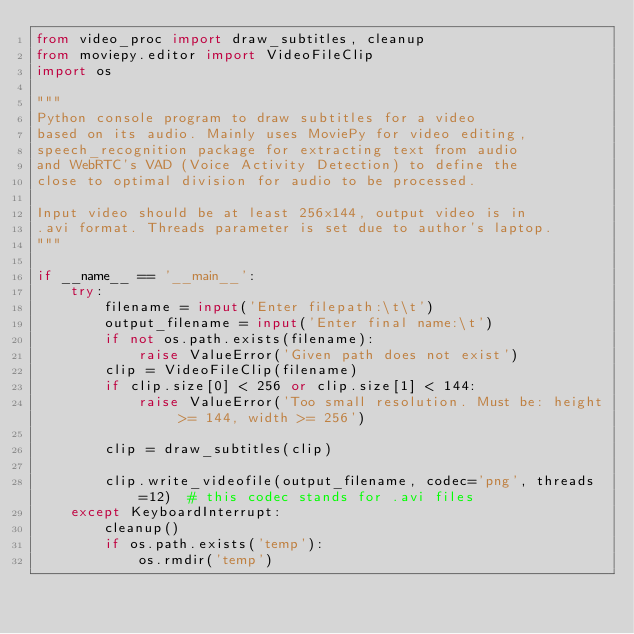<code> <loc_0><loc_0><loc_500><loc_500><_Python_>from video_proc import draw_subtitles, cleanup
from moviepy.editor import VideoFileClip
import os

"""
Python console program to draw subtitles for a video
based on its audio. Mainly uses MoviePy for video editing,
speech_recognition package for extracting text from audio
and WebRTC's VAD (Voice Activity Detection) to define the
close to optimal division for audio to be processed.

Input video should be at least 256x144, output video is in
.avi format. Threads parameter is set due to author's laptop.
"""

if __name__ == '__main__':
    try:
        filename = input('Enter filepath:\t\t')
        output_filename = input('Enter final name:\t')
        if not os.path.exists(filename):
            raise ValueError('Given path does not exist')
        clip = VideoFileClip(filename)
        if clip.size[0] < 256 or clip.size[1] < 144:
            raise ValueError('Too small resolution. Must be: height >= 144, width >= 256')

        clip = draw_subtitles(clip)

        clip.write_videofile(output_filename, codec='png', threads=12)  # this codec stands for .avi files
    except KeyboardInterrupt:
        cleanup()
        if os.path.exists('temp'):
            os.rmdir('temp')
</code> 